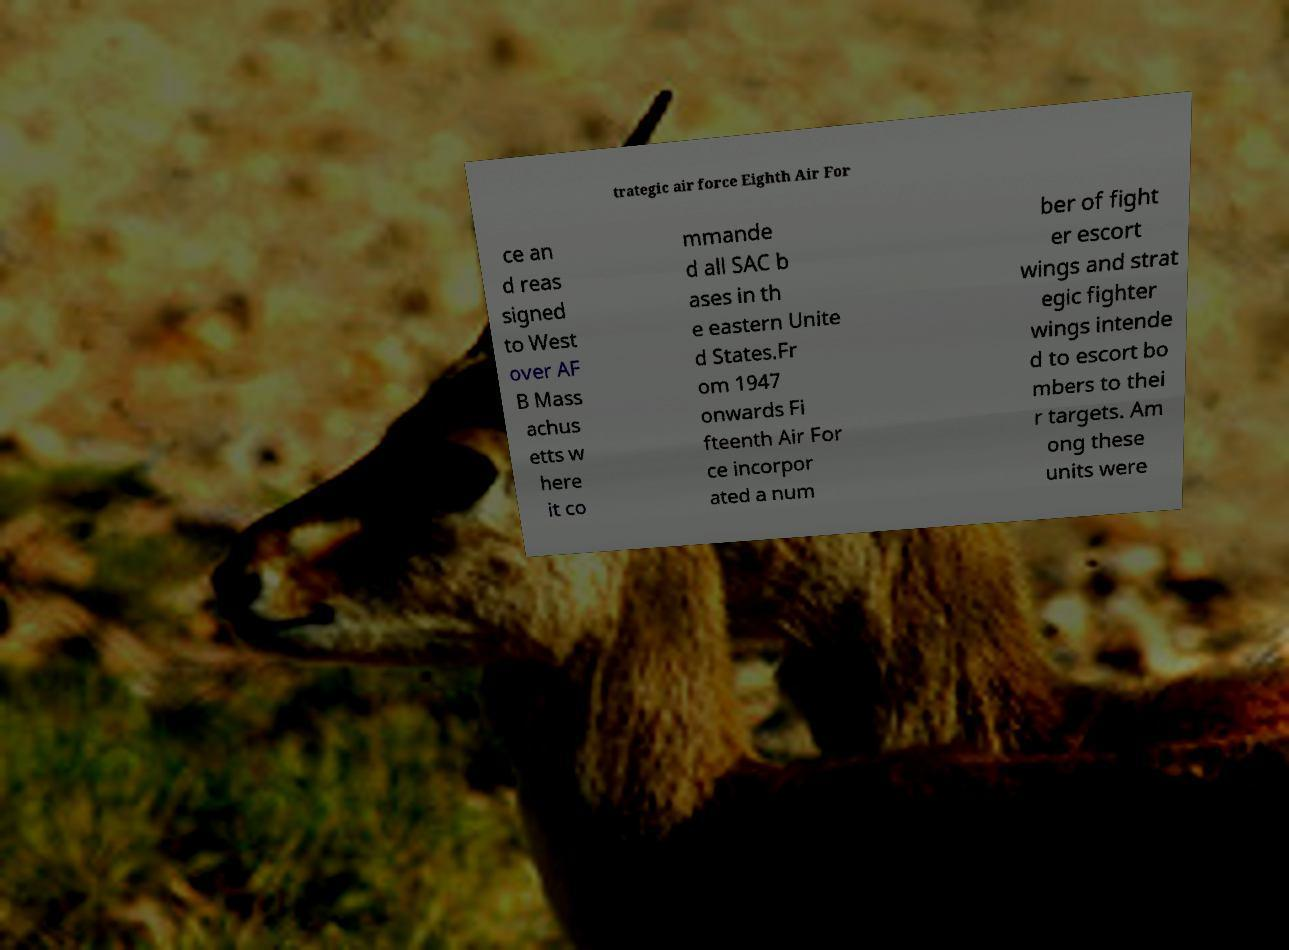Could you extract and type out the text from this image? trategic air force Eighth Air For ce an d reas signed to West over AF B Mass achus etts w here it co mmande d all SAC b ases in th e eastern Unite d States.Fr om 1947 onwards Fi fteenth Air For ce incorpor ated a num ber of fight er escort wings and strat egic fighter wings intende d to escort bo mbers to thei r targets. Am ong these units were 